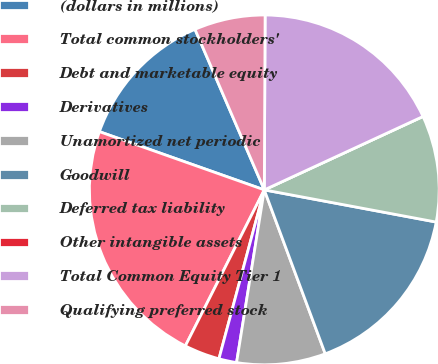Convert chart. <chart><loc_0><loc_0><loc_500><loc_500><pie_chart><fcel>(dollars in millions)<fcel>Total common stockholders'<fcel>Debt and marketable equity<fcel>Derivatives<fcel>Unamortized net periodic<fcel>Goodwill<fcel>Deferred tax liability<fcel>Other intangible assets<fcel>Total Common Equity Tier 1<fcel>Qualifying preferred stock<nl><fcel>13.11%<fcel>22.95%<fcel>3.28%<fcel>1.64%<fcel>8.2%<fcel>16.39%<fcel>9.84%<fcel>0.0%<fcel>18.03%<fcel>6.56%<nl></chart> 